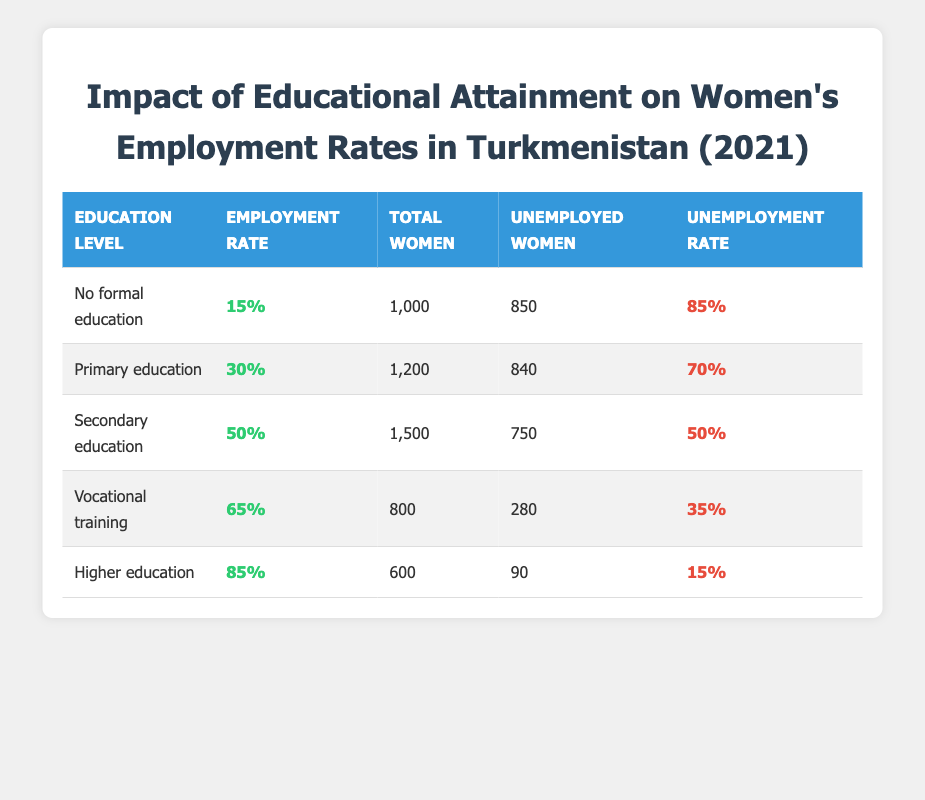What is the employment rate for women with no formal education? The employment rate for women with no formal education is explicitly stated in the table as 15%.
Answer: 15% How many unemployed women are there with primary education? The table shows that there are 840 unemployed women with primary education listed under the unemployed women column.
Answer: 840 What is the percentage of unemployment for women who have secondary education? The table indicates that the percentage of unemployment for women with secondary education is 50%.
Answer: 50% Is the unemployment rate for women with higher education less than 20%? The table shows that the unemployment rate for women with higher education is 15%, which is indeed less than 20%, confirming the statement to be true.
Answer: Yes What is the total number of women who have received vocational training? According to the table, the total number of women who have received vocational training is 800 as stated in the total women column.
Answer: 800 How many more unemployed women are there with no formal education compared to higher education? The number of unemployed women with no formal education is 850, and with higher education, it is 90. The difference is 850 - 90 = 760, meaning there are 760 more unemployed women with no formal education compared to higher education.
Answer: 760 What is the average employment rate across all education levels? The employment rates are 15%, 30%, 50%, 65%, and 85%. Summing these gives 15 + 30 + 50 + 65 + 85 = 245. Dividing by the number of education levels (5), the average is 245 / 5 = 49%.
Answer: 49% Is the total number of women with vocational training greater than the total number of women with higher education? The table shows there are 800 women with vocational training and 600 women with higher education. Since 800 is greater than 600, the statement is true.
Answer: Yes How many total women are represented in the employment data? The total number of women is calculated by adding the total women columns from each education level: 1000 + 1200 + 1500 + 800 + 600 = 4100. Therefore, 4100 women are represented in the data.
Answer: 4100 